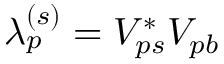<formula> <loc_0><loc_0><loc_500><loc_500>\lambda _ { p } ^ { ( s ) } = V _ { p s } ^ { * } V _ { p b }</formula> 